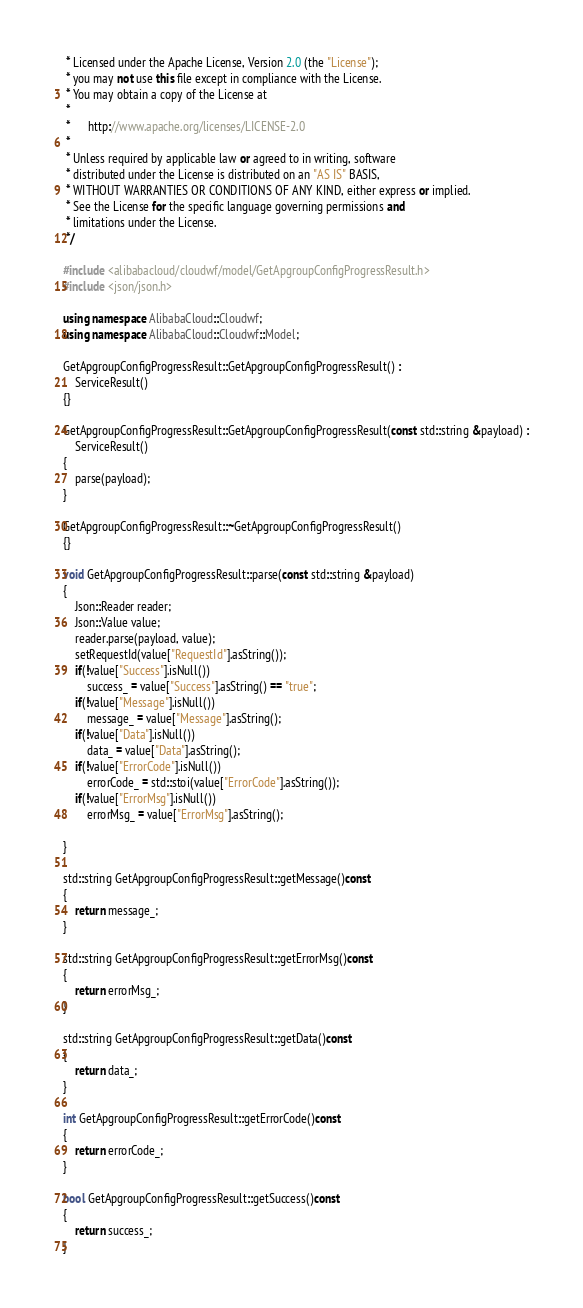Convert code to text. <code><loc_0><loc_0><loc_500><loc_500><_C++_> * Licensed under the Apache License, Version 2.0 (the "License");
 * you may not use this file except in compliance with the License.
 * You may obtain a copy of the License at
 * 
 *      http://www.apache.org/licenses/LICENSE-2.0
 * 
 * Unless required by applicable law or agreed to in writing, software
 * distributed under the License is distributed on an "AS IS" BASIS,
 * WITHOUT WARRANTIES OR CONDITIONS OF ANY KIND, either express or implied.
 * See the License for the specific language governing permissions and
 * limitations under the License.
 */

#include <alibabacloud/cloudwf/model/GetApgroupConfigProgressResult.h>
#include <json/json.h>

using namespace AlibabaCloud::Cloudwf;
using namespace AlibabaCloud::Cloudwf::Model;

GetApgroupConfigProgressResult::GetApgroupConfigProgressResult() :
	ServiceResult()
{}

GetApgroupConfigProgressResult::GetApgroupConfigProgressResult(const std::string &payload) :
	ServiceResult()
{
	parse(payload);
}

GetApgroupConfigProgressResult::~GetApgroupConfigProgressResult()
{}

void GetApgroupConfigProgressResult::parse(const std::string &payload)
{
	Json::Reader reader;
	Json::Value value;
	reader.parse(payload, value);
	setRequestId(value["RequestId"].asString());
	if(!value["Success"].isNull())
		success_ = value["Success"].asString() == "true";
	if(!value["Message"].isNull())
		message_ = value["Message"].asString();
	if(!value["Data"].isNull())
		data_ = value["Data"].asString();
	if(!value["ErrorCode"].isNull())
		errorCode_ = std::stoi(value["ErrorCode"].asString());
	if(!value["ErrorMsg"].isNull())
		errorMsg_ = value["ErrorMsg"].asString();

}

std::string GetApgroupConfigProgressResult::getMessage()const
{
	return message_;
}

std::string GetApgroupConfigProgressResult::getErrorMsg()const
{
	return errorMsg_;
}

std::string GetApgroupConfigProgressResult::getData()const
{
	return data_;
}

int GetApgroupConfigProgressResult::getErrorCode()const
{
	return errorCode_;
}

bool GetApgroupConfigProgressResult::getSuccess()const
{
	return success_;
}

</code> 